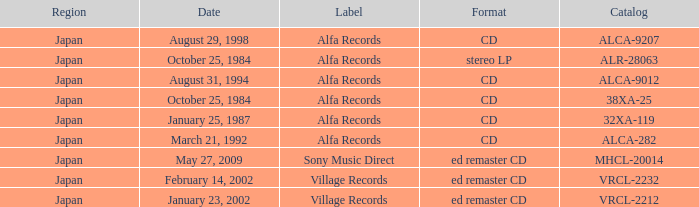What was the region of the release from May 27, 2009? Japan. 